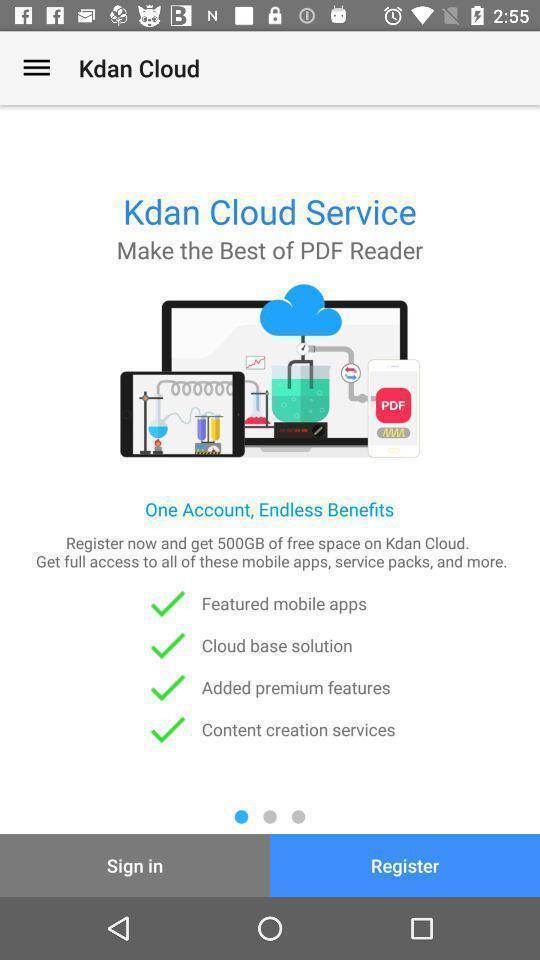Give me a summary of this screen capture. Welcome page of a pdf reader app. 